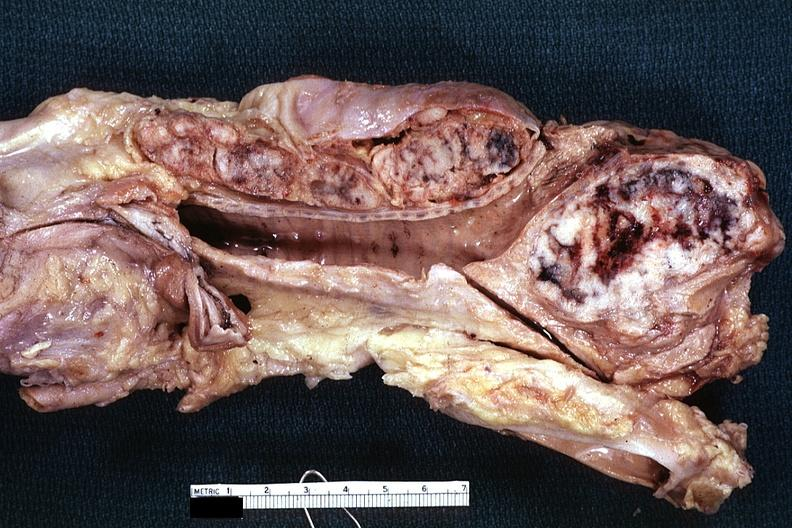s endocervical polyp present?
Answer the question using a single word or phrase. No 